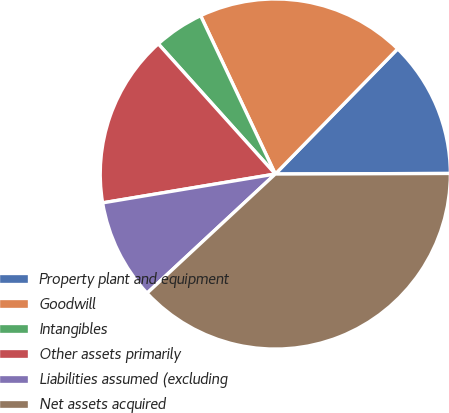<chart> <loc_0><loc_0><loc_500><loc_500><pie_chart><fcel>Property plant and equipment<fcel>Goodwill<fcel>Intangibles<fcel>Other assets primarily<fcel>Liabilities assumed (excluding<fcel>Net assets acquired<nl><fcel>12.63%<fcel>19.33%<fcel>4.64%<fcel>15.98%<fcel>9.28%<fcel>38.13%<nl></chart> 